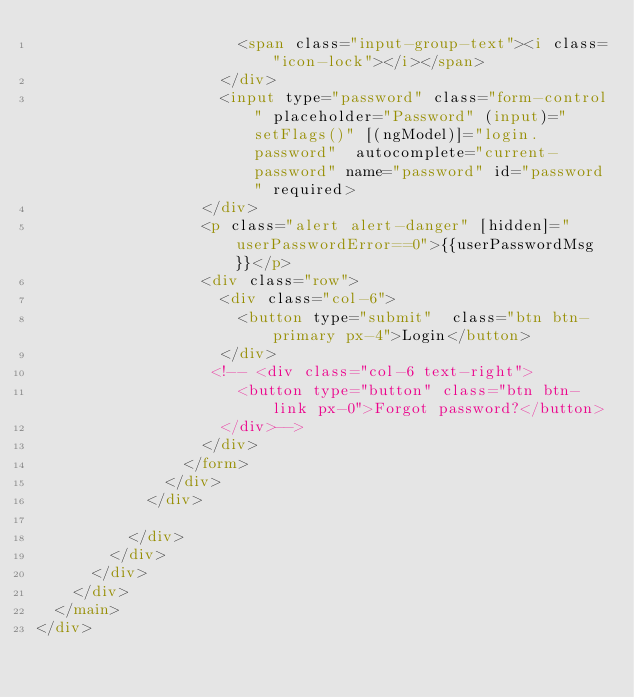Convert code to text. <code><loc_0><loc_0><loc_500><loc_500><_HTML_>                      <span class="input-group-text"><i class="icon-lock"></i></span>
                    </div>
                    <input type="password" class="form-control" placeholder="Password" (input)="setFlags()" [(ngModel)]="login.password"  autocomplete="current-password" name="password" id="password" required>
                  </div>
                  <p class="alert alert-danger" [hidden]="userPasswordError==0">{{userPasswordMsg}}</p>
                  <div class="row">
                    <div class="col-6">
                      <button type="submit"  class="btn btn-primary px-4">Login</button>
                    </div>
                   <!-- <div class="col-6 text-right">
                      <button type="button" class="btn btn-link px-0">Forgot password?</button>
                    </div>-->
                  </div>
                </form>
              </div>
            </div>
            
          </div>
        </div>
      </div>
    </div>
  </main>
</div>
</code> 